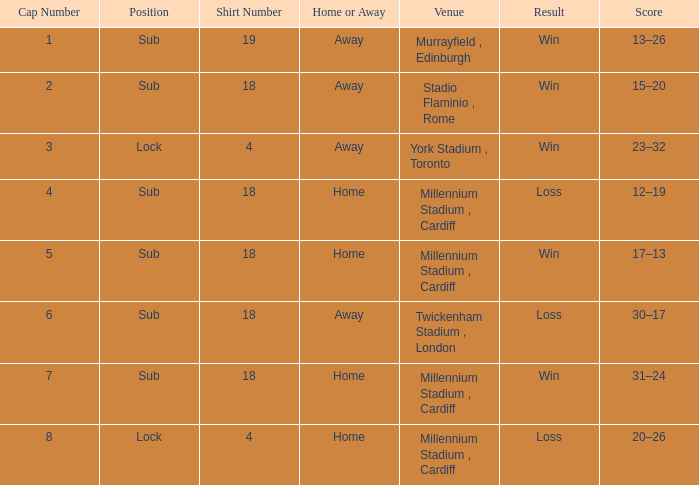Can you tell me the lowest Cap Number that has the Date of 8 february 2009, and the Shirt Number larger than 19? None. Could you help me parse every detail presented in this table? {'header': ['Cap Number', 'Position', 'Shirt Number', 'Home or Away', 'Venue', 'Result', 'Score'], 'rows': [['1', 'Sub', '19', 'Away', 'Murrayfield , Edinburgh', 'Win', '13–26'], ['2', 'Sub', '18', 'Away', 'Stadio Flaminio , Rome', 'Win', '15–20'], ['3', 'Lock', '4', 'Away', 'York Stadium , Toronto', 'Win', '23–32'], ['4', 'Sub', '18', 'Home', 'Millennium Stadium , Cardiff', 'Loss', '12–19'], ['5', 'Sub', '18', 'Home', 'Millennium Stadium , Cardiff', 'Win', '17–13'], ['6', 'Sub', '18', 'Away', 'Twickenham Stadium , London', 'Loss', '30–17'], ['7', 'Sub', '18', 'Home', 'Millennium Stadium , Cardiff', 'Win', '31–24'], ['8', 'Lock', '4', 'Home', 'Millennium Stadium , Cardiff', 'Loss', '20–26']]} 